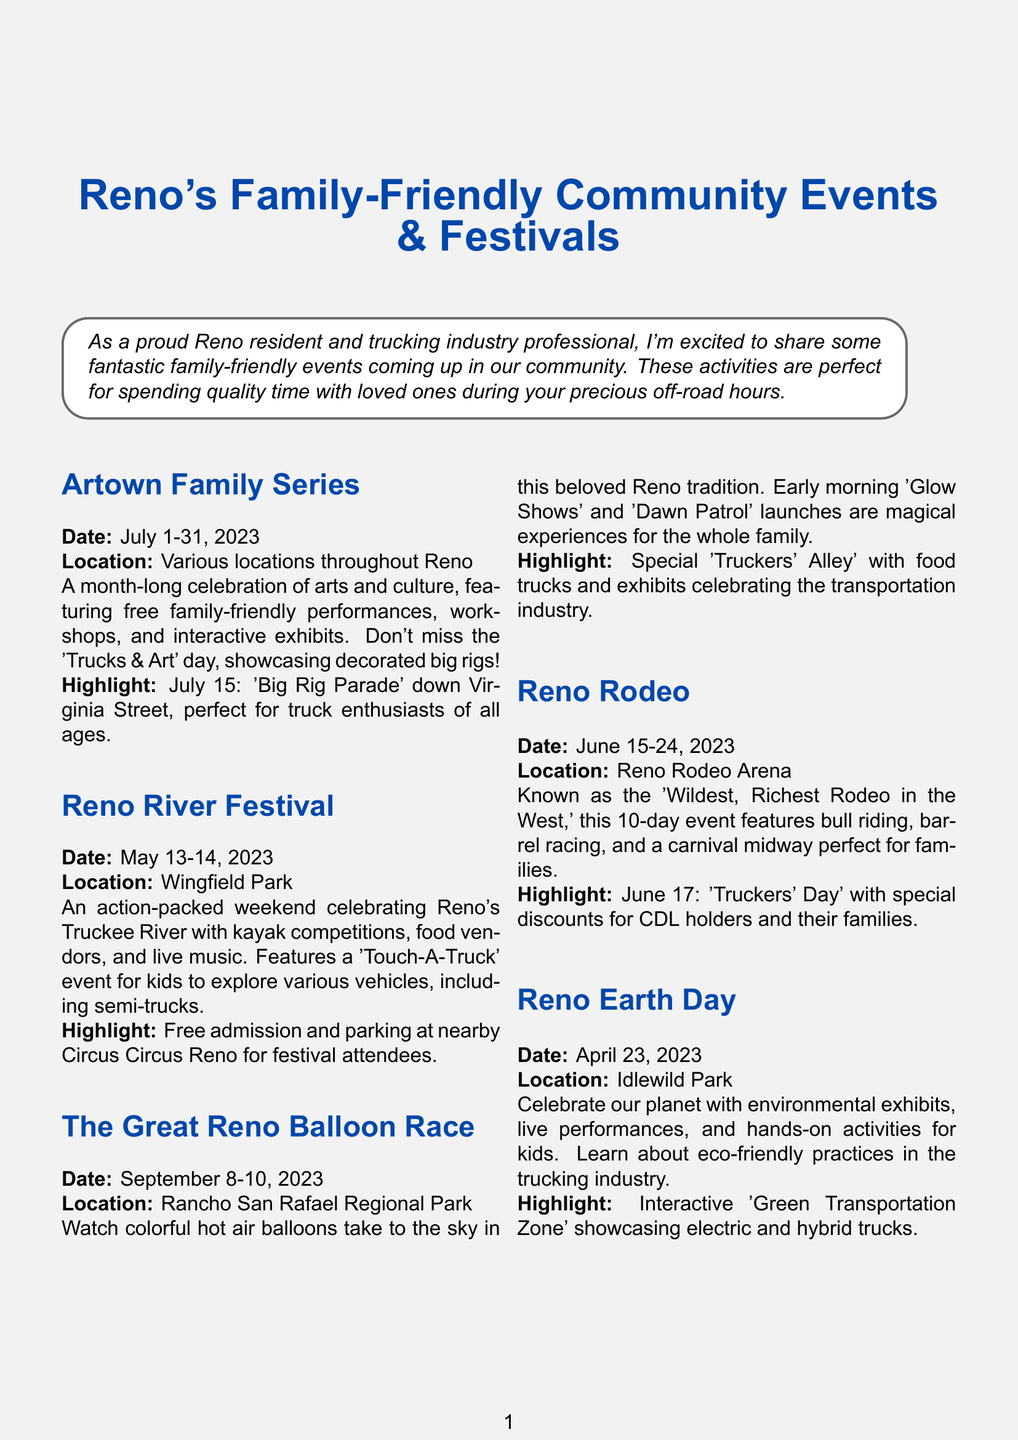What is the title of the brochure? The title of the brochure can be found at the top of the document.
Answer: Reno's Family-Friendly Community Events & Festivals What are the dates for the Reno River Festival? The dates for the Reno River Festival are specifically mentioned in the document.
Answer: May 13-14, 2023 Where is the Great Reno Balloon Race held? The location for the Great Reno Balloon Race is provided in the event description.
Answer: Rancho San Rafael Regional Park What special event is happening on June 17 during the Reno Rodeo? The document highlights specific events for certain days during the Reno Rodeo.
Answer: Truckers' Day What is the highlight of the Artown Family Series? The highlight for the Artown Family Series is included in the event details.
Answer: July 15: 'Big Rig Parade' down Virginia Street How long does the Reno Rodeo last? The duration of the Reno Rodeo is mentioned in the event description.
Answer: 10 days What specific activity can children participate in at the Reno River Festival? The document specifies activities introduced for children at the festival.
Answer: Touch-A-Truck What type of parking is available at most events? The parking availability for events is mentioned in the additional information section.
Answer: Free or discounted What is a resource for planning transportation to event locations? The transportation resources are provided in the additional information section of the brochure.
Answer: rtcwashoe.com 